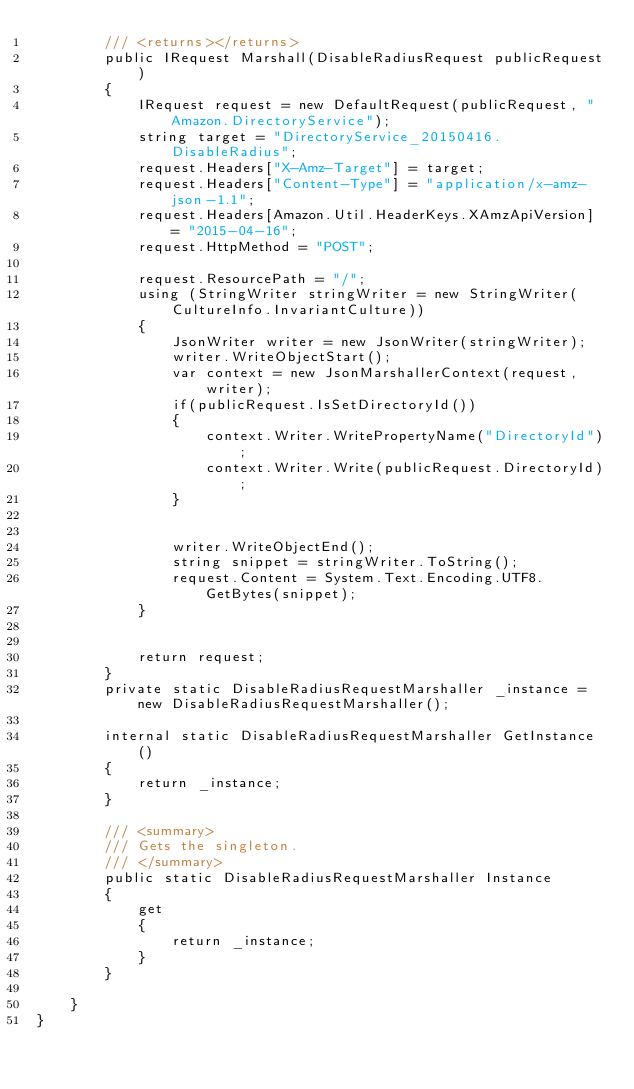Convert code to text. <code><loc_0><loc_0><loc_500><loc_500><_C#_>        /// <returns></returns>
        public IRequest Marshall(DisableRadiusRequest publicRequest)
        {
            IRequest request = new DefaultRequest(publicRequest, "Amazon.DirectoryService");
            string target = "DirectoryService_20150416.DisableRadius";
            request.Headers["X-Amz-Target"] = target;
            request.Headers["Content-Type"] = "application/x-amz-json-1.1";
            request.Headers[Amazon.Util.HeaderKeys.XAmzApiVersion] = "2015-04-16";            
            request.HttpMethod = "POST";

            request.ResourcePath = "/";
            using (StringWriter stringWriter = new StringWriter(CultureInfo.InvariantCulture))
            {
                JsonWriter writer = new JsonWriter(stringWriter);
                writer.WriteObjectStart();
                var context = new JsonMarshallerContext(request, writer);
                if(publicRequest.IsSetDirectoryId())
                {
                    context.Writer.WritePropertyName("DirectoryId");
                    context.Writer.Write(publicRequest.DirectoryId);
                }

        
                writer.WriteObjectEnd();
                string snippet = stringWriter.ToString();
                request.Content = System.Text.Encoding.UTF8.GetBytes(snippet);
            }


            return request;
        }
        private static DisableRadiusRequestMarshaller _instance = new DisableRadiusRequestMarshaller();        

        internal static DisableRadiusRequestMarshaller GetInstance()
        {
            return _instance;
        }

        /// <summary>
        /// Gets the singleton.
        /// </summary>  
        public static DisableRadiusRequestMarshaller Instance
        {
            get
            {
                return _instance;
            }
        }

    }
}</code> 